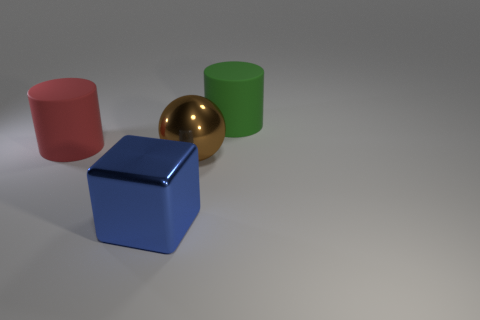Add 4 tiny green things. How many objects exist? 8 Subtract all cubes. How many objects are left? 3 Subtract 0 yellow cylinders. How many objects are left? 4 Subtract all large cyan metal cylinders. Subtract all large brown shiny things. How many objects are left? 3 Add 2 balls. How many balls are left? 3 Add 3 brown spheres. How many brown spheres exist? 4 